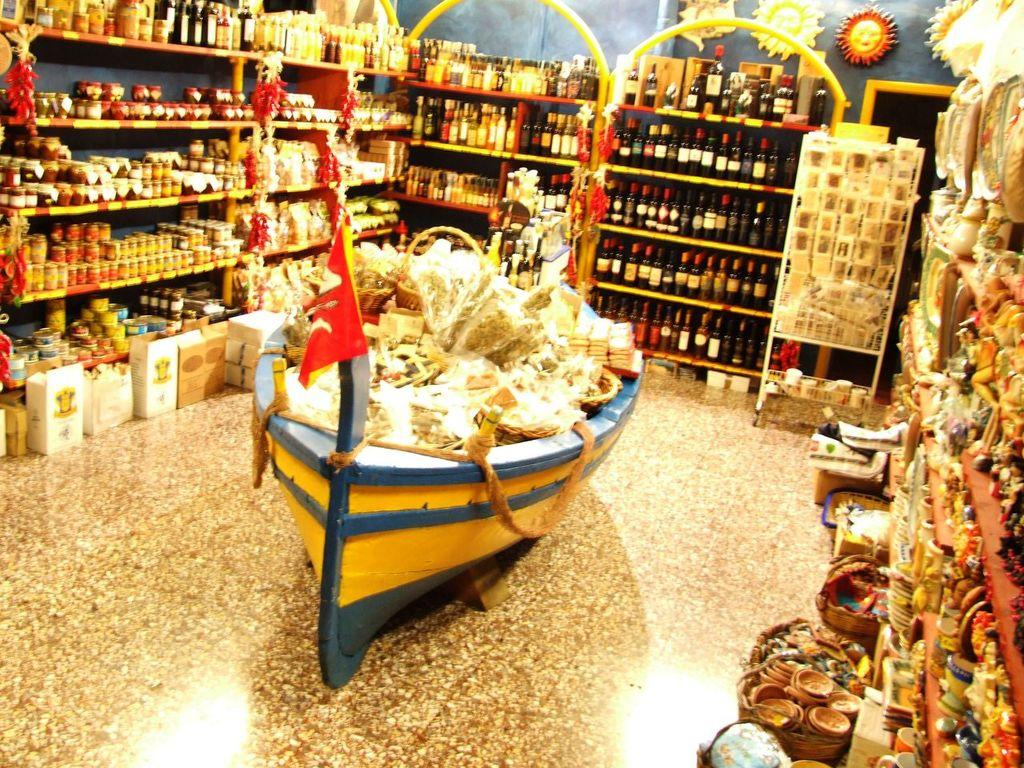What type of space is depicted in the image? There is a room in the image. What can be seen inside the room? There are bottles and other things arranged in the room. Can you describe a specific object in the room? There is a boat-like object in the room. What is placed inside the boat-like object? There are things placed inside the boat-like object. How many ducks are swimming in the water near the boat-like object in the image? There are no ducks or water present in the image; it features a room with a boat-like object and other objects. 